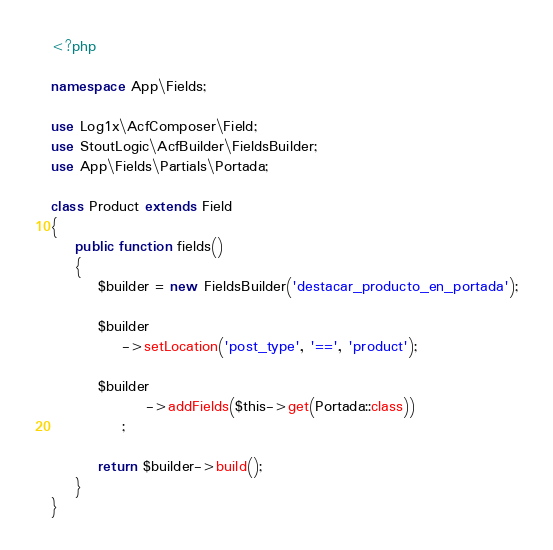Convert code to text. <code><loc_0><loc_0><loc_500><loc_500><_PHP_><?php

namespace App\Fields;

use Log1x\AcfComposer\Field;
use StoutLogic\AcfBuilder\FieldsBuilder;
use App\Fields\Partials\Portada;

class Product extends Field
{
    public function fields()
    {
        $builder = new FieldsBuilder('destacar_producto_en_portada');

        $builder
            ->setLocation('post_type', '==', 'product');

        $builder
                ->addFields($this->get(Portada::class))
            ;

        return $builder->build();
    }
}
</code> 